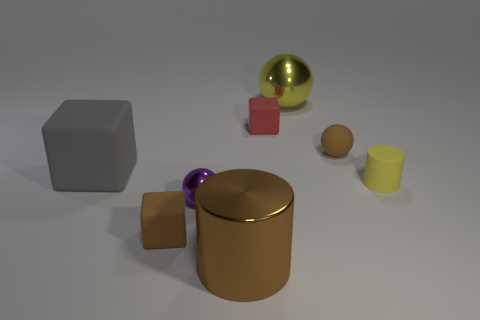How does lighting affect the mood or look of this image? The lighting in this image creates soft shadows and subtly highlights the contours of the objects, providing a calm and gentle ambiance. It seems diffuse, with no harsh or overly dramatic contrasts, which adds to the serene and balanced composition of the scene. The smooth reflections on the metallic and shiny objects are accentuated by the lighting, giving the image depth and a sophisticated look. 